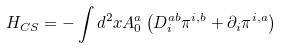Convert formula to latex. <formula><loc_0><loc_0><loc_500><loc_500>H _ { C S } = - \int d ^ { 2 } { x } A _ { 0 } ^ { a } \left ( D _ { i } ^ { a b } \pi ^ { i , b } + \partial _ { i } \pi ^ { i , a } \right )</formula> 